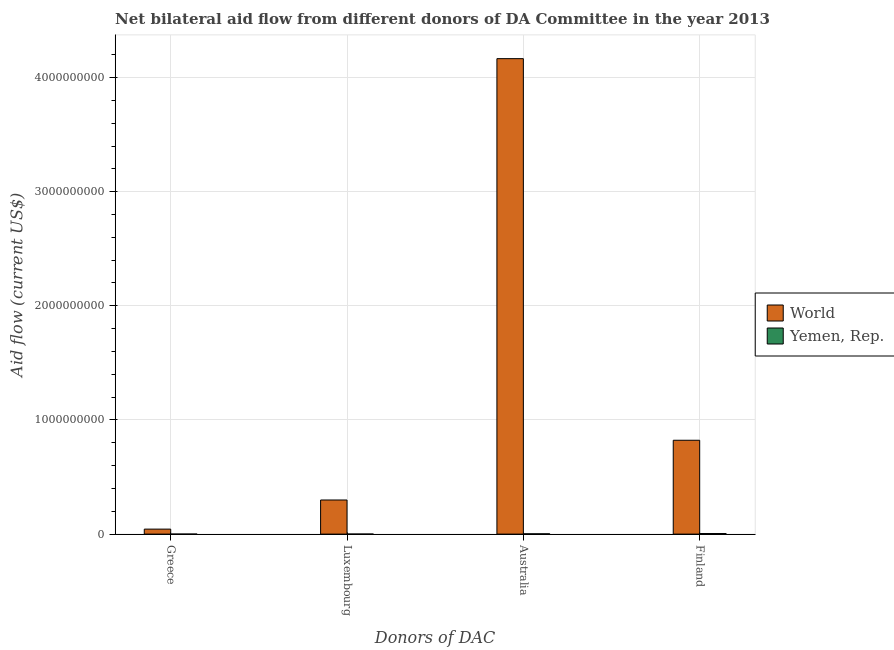How many different coloured bars are there?
Give a very brief answer. 2. Are the number of bars per tick equal to the number of legend labels?
Your response must be concise. Yes. What is the amount of aid given by finland in World?
Ensure brevity in your answer.  8.22e+08. Across all countries, what is the maximum amount of aid given by australia?
Your answer should be very brief. 4.17e+09. Across all countries, what is the minimum amount of aid given by finland?
Your answer should be very brief. 5.12e+06. In which country was the amount of aid given by australia minimum?
Ensure brevity in your answer.  Yemen, Rep. What is the total amount of aid given by finland in the graph?
Ensure brevity in your answer.  8.27e+08. What is the difference between the amount of aid given by australia in World and that in Yemen, Rep.?
Your response must be concise. 4.16e+09. What is the difference between the amount of aid given by australia in Yemen, Rep. and the amount of aid given by greece in World?
Keep it short and to the point. -4.12e+07. What is the average amount of aid given by greece per country?
Offer a terse response. 2.18e+07. What is the difference between the amount of aid given by greece and amount of aid given by luxembourg in Yemen, Rep.?
Provide a short and direct response. -2.60e+05. In how many countries, is the amount of aid given by finland greater than 1600000000 US$?
Your answer should be very brief. 0. What is the ratio of the amount of aid given by finland in World to that in Yemen, Rep.?
Make the answer very short. 160.59. What is the difference between the highest and the second highest amount of aid given by finland?
Give a very brief answer. 8.17e+08. What is the difference between the highest and the lowest amount of aid given by finland?
Provide a succinct answer. 8.17e+08. What does the 1st bar from the left in Greece represents?
Give a very brief answer. World. How many bars are there?
Your answer should be very brief. 8. How many countries are there in the graph?
Offer a terse response. 2. What is the difference between two consecutive major ticks on the Y-axis?
Offer a terse response. 1.00e+09. Does the graph contain any zero values?
Offer a terse response. No. Does the graph contain grids?
Your answer should be very brief. Yes. What is the title of the graph?
Your answer should be compact. Net bilateral aid flow from different donors of DA Committee in the year 2013. What is the label or title of the X-axis?
Offer a terse response. Donors of DAC. What is the label or title of the Y-axis?
Your answer should be compact. Aid flow (current US$). What is the Aid flow (current US$) of World in Greece?
Ensure brevity in your answer.  4.36e+07. What is the Aid flow (current US$) of World in Luxembourg?
Your answer should be compact. 2.99e+08. What is the Aid flow (current US$) in World in Australia?
Ensure brevity in your answer.  4.17e+09. What is the Aid flow (current US$) in Yemen, Rep. in Australia?
Your answer should be compact. 2.47e+06. What is the Aid flow (current US$) in World in Finland?
Your response must be concise. 8.22e+08. What is the Aid flow (current US$) in Yemen, Rep. in Finland?
Make the answer very short. 5.12e+06. Across all Donors of DAC, what is the maximum Aid flow (current US$) of World?
Offer a very short reply. 4.17e+09. Across all Donors of DAC, what is the maximum Aid flow (current US$) in Yemen, Rep.?
Ensure brevity in your answer.  5.12e+06. Across all Donors of DAC, what is the minimum Aid flow (current US$) of World?
Give a very brief answer. 4.36e+07. What is the total Aid flow (current US$) in World in the graph?
Make the answer very short. 5.33e+09. What is the total Aid flow (current US$) in Yemen, Rep. in the graph?
Give a very brief answer. 7.87e+06. What is the difference between the Aid flow (current US$) in World in Greece and that in Luxembourg?
Provide a short and direct response. -2.55e+08. What is the difference between the Aid flow (current US$) in Yemen, Rep. in Greece and that in Luxembourg?
Offer a terse response. -2.60e+05. What is the difference between the Aid flow (current US$) in World in Greece and that in Australia?
Provide a short and direct response. -4.12e+09. What is the difference between the Aid flow (current US$) of Yemen, Rep. in Greece and that in Australia?
Your answer should be compact. -2.46e+06. What is the difference between the Aid flow (current US$) in World in Greece and that in Finland?
Make the answer very short. -7.79e+08. What is the difference between the Aid flow (current US$) of Yemen, Rep. in Greece and that in Finland?
Your answer should be compact. -5.11e+06. What is the difference between the Aid flow (current US$) in World in Luxembourg and that in Australia?
Give a very brief answer. -3.87e+09. What is the difference between the Aid flow (current US$) in Yemen, Rep. in Luxembourg and that in Australia?
Give a very brief answer. -2.20e+06. What is the difference between the Aid flow (current US$) in World in Luxembourg and that in Finland?
Make the answer very short. -5.23e+08. What is the difference between the Aid flow (current US$) in Yemen, Rep. in Luxembourg and that in Finland?
Your answer should be compact. -4.85e+06. What is the difference between the Aid flow (current US$) of World in Australia and that in Finland?
Provide a short and direct response. 3.34e+09. What is the difference between the Aid flow (current US$) in Yemen, Rep. in Australia and that in Finland?
Offer a very short reply. -2.65e+06. What is the difference between the Aid flow (current US$) in World in Greece and the Aid flow (current US$) in Yemen, Rep. in Luxembourg?
Make the answer very short. 4.34e+07. What is the difference between the Aid flow (current US$) of World in Greece and the Aid flow (current US$) of Yemen, Rep. in Australia?
Make the answer very short. 4.12e+07. What is the difference between the Aid flow (current US$) in World in Greece and the Aid flow (current US$) in Yemen, Rep. in Finland?
Your response must be concise. 3.85e+07. What is the difference between the Aid flow (current US$) of World in Luxembourg and the Aid flow (current US$) of Yemen, Rep. in Australia?
Make the answer very short. 2.96e+08. What is the difference between the Aid flow (current US$) in World in Luxembourg and the Aid flow (current US$) in Yemen, Rep. in Finland?
Provide a succinct answer. 2.94e+08. What is the difference between the Aid flow (current US$) of World in Australia and the Aid flow (current US$) of Yemen, Rep. in Finland?
Provide a succinct answer. 4.16e+09. What is the average Aid flow (current US$) of World per Donors of DAC?
Keep it short and to the point. 1.33e+09. What is the average Aid flow (current US$) in Yemen, Rep. per Donors of DAC?
Give a very brief answer. 1.97e+06. What is the difference between the Aid flow (current US$) of World and Aid flow (current US$) of Yemen, Rep. in Greece?
Your answer should be very brief. 4.36e+07. What is the difference between the Aid flow (current US$) in World and Aid flow (current US$) in Yemen, Rep. in Luxembourg?
Offer a very short reply. 2.99e+08. What is the difference between the Aid flow (current US$) of World and Aid flow (current US$) of Yemen, Rep. in Australia?
Give a very brief answer. 4.16e+09. What is the difference between the Aid flow (current US$) in World and Aid flow (current US$) in Yemen, Rep. in Finland?
Offer a very short reply. 8.17e+08. What is the ratio of the Aid flow (current US$) in World in Greece to that in Luxembourg?
Keep it short and to the point. 0.15. What is the ratio of the Aid flow (current US$) in Yemen, Rep. in Greece to that in Luxembourg?
Offer a very short reply. 0.04. What is the ratio of the Aid flow (current US$) of World in Greece to that in Australia?
Give a very brief answer. 0.01. What is the ratio of the Aid flow (current US$) in Yemen, Rep. in Greece to that in Australia?
Your response must be concise. 0. What is the ratio of the Aid flow (current US$) of World in Greece to that in Finland?
Your response must be concise. 0.05. What is the ratio of the Aid flow (current US$) of Yemen, Rep. in Greece to that in Finland?
Your response must be concise. 0. What is the ratio of the Aid flow (current US$) in World in Luxembourg to that in Australia?
Ensure brevity in your answer.  0.07. What is the ratio of the Aid flow (current US$) of Yemen, Rep. in Luxembourg to that in Australia?
Your response must be concise. 0.11. What is the ratio of the Aid flow (current US$) of World in Luxembourg to that in Finland?
Make the answer very short. 0.36. What is the ratio of the Aid flow (current US$) in Yemen, Rep. in Luxembourg to that in Finland?
Keep it short and to the point. 0.05. What is the ratio of the Aid flow (current US$) in World in Australia to that in Finland?
Provide a succinct answer. 5.07. What is the ratio of the Aid flow (current US$) of Yemen, Rep. in Australia to that in Finland?
Give a very brief answer. 0.48. What is the difference between the highest and the second highest Aid flow (current US$) in World?
Ensure brevity in your answer.  3.34e+09. What is the difference between the highest and the second highest Aid flow (current US$) of Yemen, Rep.?
Your response must be concise. 2.65e+06. What is the difference between the highest and the lowest Aid flow (current US$) of World?
Your answer should be compact. 4.12e+09. What is the difference between the highest and the lowest Aid flow (current US$) in Yemen, Rep.?
Give a very brief answer. 5.11e+06. 